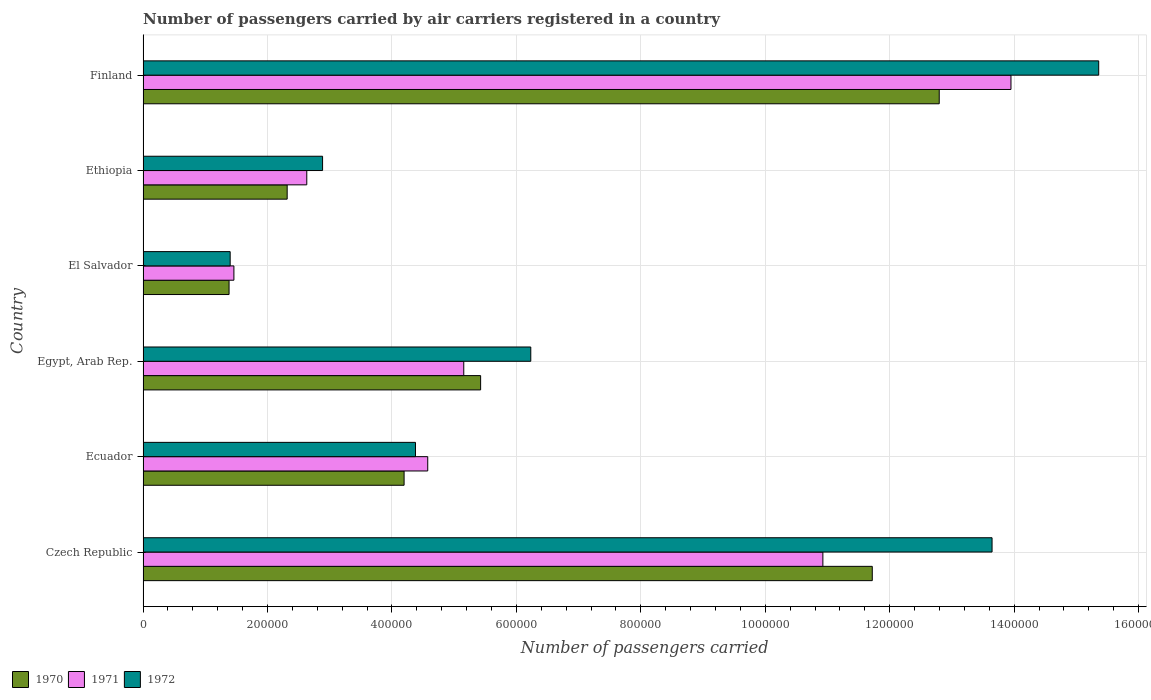How many groups of bars are there?
Give a very brief answer. 6. Are the number of bars per tick equal to the number of legend labels?
Your response must be concise. Yes. Are the number of bars on each tick of the Y-axis equal?
Your answer should be very brief. Yes. How many bars are there on the 5th tick from the bottom?
Your response must be concise. 3. What is the label of the 2nd group of bars from the top?
Offer a terse response. Ethiopia. What is the number of passengers carried by air carriers in 1970 in Ecuador?
Offer a terse response. 4.20e+05. Across all countries, what is the maximum number of passengers carried by air carriers in 1972?
Offer a very short reply. 1.54e+06. In which country was the number of passengers carried by air carriers in 1971 minimum?
Give a very brief answer. El Salvador. What is the total number of passengers carried by air carriers in 1970 in the graph?
Your answer should be compact. 3.78e+06. What is the difference between the number of passengers carried by air carriers in 1972 in El Salvador and that in Ethiopia?
Keep it short and to the point. -1.48e+05. What is the difference between the number of passengers carried by air carriers in 1971 in El Salvador and the number of passengers carried by air carriers in 1972 in Finland?
Offer a very short reply. -1.39e+06. What is the average number of passengers carried by air carriers in 1970 per country?
Make the answer very short. 6.31e+05. What is the difference between the number of passengers carried by air carriers in 1971 and number of passengers carried by air carriers in 1970 in Finland?
Ensure brevity in your answer.  1.15e+05. In how many countries, is the number of passengers carried by air carriers in 1970 greater than 1080000 ?
Provide a short and direct response. 2. What is the ratio of the number of passengers carried by air carriers in 1970 in El Salvador to that in Finland?
Give a very brief answer. 0.11. Is the number of passengers carried by air carriers in 1972 in Egypt, Arab Rep. less than that in Ethiopia?
Make the answer very short. No. What is the difference between the highest and the second highest number of passengers carried by air carriers in 1972?
Give a very brief answer. 1.71e+05. What is the difference between the highest and the lowest number of passengers carried by air carriers in 1970?
Give a very brief answer. 1.14e+06. In how many countries, is the number of passengers carried by air carriers in 1971 greater than the average number of passengers carried by air carriers in 1971 taken over all countries?
Your answer should be very brief. 2. What does the 2nd bar from the top in Czech Republic represents?
Your answer should be very brief. 1971. What does the 1st bar from the bottom in Ecuador represents?
Make the answer very short. 1970. Are all the bars in the graph horizontal?
Offer a terse response. Yes. How many countries are there in the graph?
Provide a succinct answer. 6. Are the values on the major ticks of X-axis written in scientific E-notation?
Provide a succinct answer. No. Does the graph contain grids?
Your answer should be compact. Yes. Where does the legend appear in the graph?
Provide a succinct answer. Bottom left. How many legend labels are there?
Offer a terse response. 3. What is the title of the graph?
Provide a succinct answer. Number of passengers carried by air carriers registered in a country. Does "1988" appear as one of the legend labels in the graph?
Offer a terse response. No. What is the label or title of the X-axis?
Provide a succinct answer. Number of passengers carried. What is the label or title of the Y-axis?
Give a very brief answer. Country. What is the Number of passengers carried in 1970 in Czech Republic?
Ensure brevity in your answer.  1.17e+06. What is the Number of passengers carried of 1971 in Czech Republic?
Your answer should be very brief. 1.09e+06. What is the Number of passengers carried of 1972 in Czech Republic?
Offer a terse response. 1.36e+06. What is the Number of passengers carried in 1970 in Ecuador?
Your answer should be very brief. 4.20e+05. What is the Number of passengers carried in 1971 in Ecuador?
Your response must be concise. 4.58e+05. What is the Number of passengers carried in 1972 in Ecuador?
Your answer should be very brief. 4.38e+05. What is the Number of passengers carried in 1970 in Egypt, Arab Rep.?
Give a very brief answer. 5.42e+05. What is the Number of passengers carried of 1971 in Egypt, Arab Rep.?
Your response must be concise. 5.15e+05. What is the Number of passengers carried in 1972 in Egypt, Arab Rep.?
Ensure brevity in your answer.  6.23e+05. What is the Number of passengers carried in 1970 in El Salvador?
Give a very brief answer. 1.38e+05. What is the Number of passengers carried of 1971 in El Salvador?
Your response must be concise. 1.46e+05. What is the Number of passengers carried of 1972 in El Salvador?
Your answer should be very brief. 1.40e+05. What is the Number of passengers carried in 1970 in Ethiopia?
Your response must be concise. 2.32e+05. What is the Number of passengers carried of 1971 in Ethiopia?
Give a very brief answer. 2.63e+05. What is the Number of passengers carried of 1972 in Ethiopia?
Provide a succinct answer. 2.88e+05. What is the Number of passengers carried in 1970 in Finland?
Offer a terse response. 1.28e+06. What is the Number of passengers carried in 1971 in Finland?
Keep it short and to the point. 1.39e+06. What is the Number of passengers carried in 1972 in Finland?
Offer a very short reply. 1.54e+06. Across all countries, what is the maximum Number of passengers carried of 1970?
Offer a very short reply. 1.28e+06. Across all countries, what is the maximum Number of passengers carried in 1971?
Provide a succinct answer. 1.39e+06. Across all countries, what is the maximum Number of passengers carried in 1972?
Your answer should be compact. 1.54e+06. Across all countries, what is the minimum Number of passengers carried of 1970?
Give a very brief answer. 1.38e+05. Across all countries, what is the minimum Number of passengers carried of 1971?
Provide a short and direct response. 1.46e+05. What is the total Number of passengers carried in 1970 in the graph?
Your answer should be very brief. 3.78e+06. What is the total Number of passengers carried of 1971 in the graph?
Your response must be concise. 3.87e+06. What is the total Number of passengers carried in 1972 in the graph?
Give a very brief answer. 4.39e+06. What is the difference between the Number of passengers carried of 1970 in Czech Republic and that in Ecuador?
Your answer should be compact. 7.52e+05. What is the difference between the Number of passengers carried in 1971 in Czech Republic and that in Ecuador?
Make the answer very short. 6.35e+05. What is the difference between the Number of passengers carried in 1972 in Czech Republic and that in Ecuador?
Provide a short and direct response. 9.27e+05. What is the difference between the Number of passengers carried in 1970 in Czech Republic and that in Egypt, Arab Rep.?
Give a very brief answer. 6.29e+05. What is the difference between the Number of passengers carried in 1971 in Czech Republic and that in Egypt, Arab Rep.?
Your response must be concise. 5.77e+05. What is the difference between the Number of passengers carried of 1972 in Czech Republic and that in Egypt, Arab Rep.?
Make the answer very short. 7.41e+05. What is the difference between the Number of passengers carried in 1970 in Czech Republic and that in El Salvador?
Offer a terse response. 1.03e+06. What is the difference between the Number of passengers carried of 1971 in Czech Republic and that in El Salvador?
Keep it short and to the point. 9.46e+05. What is the difference between the Number of passengers carried in 1972 in Czech Republic and that in El Salvador?
Offer a terse response. 1.22e+06. What is the difference between the Number of passengers carried of 1970 in Czech Republic and that in Ethiopia?
Keep it short and to the point. 9.40e+05. What is the difference between the Number of passengers carried of 1971 in Czech Republic and that in Ethiopia?
Make the answer very short. 8.29e+05. What is the difference between the Number of passengers carried in 1972 in Czech Republic and that in Ethiopia?
Keep it short and to the point. 1.08e+06. What is the difference between the Number of passengers carried of 1970 in Czech Republic and that in Finland?
Your response must be concise. -1.08e+05. What is the difference between the Number of passengers carried in 1971 in Czech Republic and that in Finland?
Give a very brief answer. -3.02e+05. What is the difference between the Number of passengers carried in 1972 in Czech Republic and that in Finland?
Provide a short and direct response. -1.71e+05. What is the difference between the Number of passengers carried of 1970 in Ecuador and that in Egypt, Arab Rep.?
Provide a short and direct response. -1.23e+05. What is the difference between the Number of passengers carried of 1971 in Ecuador and that in Egypt, Arab Rep.?
Ensure brevity in your answer.  -5.79e+04. What is the difference between the Number of passengers carried in 1972 in Ecuador and that in Egypt, Arab Rep.?
Provide a succinct answer. -1.85e+05. What is the difference between the Number of passengers carried in 1970 in Ecuador and that in El Salvador?
Give a very brief answer. 2.81e+05. What is the difference between the Number of passengers carried of 1971 in Ecuador and that in El Salvador?
Offer a terse response. 3.12e+05. What is the difference between the Number of passengers carried of 1972 in Ecuador and that in El Salvador?
Make the answer very short. 2.98e+05. What is the difference between the Number of passengers carried of 1970 in Ecuador and that in Ethiopia?
Give a very brief answer. 1.88e+05. What is the difference between the Number of passengers carried in 1971 in Ecuador and that in Ethiopia?
Offer a terse response. 1.94e+05. What is the difference between the Number of passengers carried in 1972 in Ecuador and that in Ethiopia?
Keep it short and to the point. 1.49e+05. What is the difference between the Number of passengers carried in 1970 in Ecuador and that in Finland?
Make the answer very short. -8.60e+05. What is the difference between the Number of passengers carried in 1971 in Ecuador and that in Finland?
Ensure brevity in your answer.  -9.37e+05. What is the difference between the Number of passengers carried of 1972 in Ecuador and that in Finland?
Your answer should be very brief. -1.10e+06. What is the difference between the Number of passengers carried in 1970 in Egypt, Arab Rep. and that in El Salvador?
Your response must be concise. 4.04e+05. What is the difference between the Number of passengers carried of 1971 in Egypt, Arab Rep. and that in El Salvador?
Ensure brevity in your answer.  3.69e+05. What is the difference between the Number of passengers carried in 1972 in Egypt, Arab Rep. and that in El Salvador?
Keep it short and to the point. 4.83e+05. What is the difference between the Number of passengers carried of 1970 in Egypt, Arab Rep. and that in Ethiopia?
Offer a terse response. 3.11e+05. What is the difference between the Number of passengers carried of 1971 in Egypt, Arab Rep. and that in Ethiopia?
Provide a short and direct response. 2.52e+05. What is the difference between the Number of passengers carried in 1972 in Egypt, Arab Rep. and that in Ethiopia?
Ensure brevity in your answer.  3.35e+05. What is the difference between the Number of passengers carried in 1970 in Egypt, Arab Rep. and that in Finland?
Ensure brevity in your answer.  -7.37e+05. What is the difference between the Number of passengers carried in 1971 in Egypt, Arab Rep. and that in Finland?
Keep it short and to the point. -8.79e+05. What is the difference between the Number of passengers carried in 1972 in Egypt, Arab Rep. and that in Finland?
Offer a terse response. -9.13e+05. What is the difference between the Number of passengers carried in 1970 in El Salvador and that in Ethiopia?
Give a very brief answer. -9.34e+04. What is the difference between the Number of passengers carried in 1971 in El Salvador and that in Ethiopia?
Your answer should be compact. -1.17e+05. What is the difference between the Number of passengers carried in 1972 in El Salvador and that in Ethiopia?
Give a very brief answer. -1.48e+05. What is the difference between the Number of passengers carried in 1970 in El Salvador and that in Finland?
Your response must be concise. -1.14e+06. What is the difference between the Number of passengers carried of 1971 in El Salvador and that in Finland?
Offer a terse response. -1.25e+06. What is the difference between the Number of passengers carried of 1972 in El Salvador and that in Finland?
Your response must be concise. -1.40e+06. What is the difference between the Number of passengers carried in 1970 in Ethiopia and that in Finland?
Offer a very short reply. -1.05e+06. What is the difference between the Number of passengers carried in 1971 in Ethiopia and that in Finland?
Make the answer very short. -1.13e+06. What is the difference between the Number of passengers carried of 1972 in Ethiopia and that in Finland?
Your answer should be very brief. -1.25e+06. What is the difference between the Number of passengers carried in 1970 in Czech Republic and the Number of passengers carried in 1971 in Ecuador?
Provide a succinct answer. 7.14e+05. What is the difference between the Number of passengers carried in 1970 in Czech Republic and the Number of passengers carried in 1972 in Ecuador?
Offer a terse response. 7.34e+05. What is the difference between the Number of passengers carried in 1971 in Czech Republic and the Number of passengers carried in 1972 in Ecuador?
Keep it short and to the point. 6.55e+05. What is the difference between the Number of passengers carried in 1970 in Czech Republic and the Number of passengers carried in 1971 in Egypt, Arab Rep.?
Make the answer very short. 6.56e+05. What is the difference between the Number of passengers carried of 1970 in Czech Republic and the Number of passengers carried of 1972 in Egypt, Arab Rep.?
Provide a succinct answer. 5.49e+05. What is the difference between the Number of passengers carried of 1971 in Czech Republic and the Number of passengers carried of 1972 in Egypt, Arab Rep.?
Provide a succinct answer. 4.69e+05. What is the difference between the Number of passengers carried in 1970 in Czech Republic and the Number of passengers carried in 1971 in El Salvador?
Give a very brief answer. 1.03e+06. What is the difference between the Number of passengers carried in 1970 in Czech Republic and the Number of passengers carried in 1972 in El Salvador?
Make the answer very short. 1.03e+06. What is the difference between the Number of passengers carried in 1971 in Czech Republic and the Number of passengers carried in 1972 in El Salvador?
Ensure brevity in your answer.  9.52e+05. What is the difference between the Number of passengers carried in 1970 in Czech Republic and the Number of passengers carried in 1971 in Ethiopia?
Offer a terse response. 9.09e+05. What is the difference between the Number of passengers carried of 1970 in Czech Republic and the Number of passengers carried of 1972 in Ethiopia?
Your response must be concise. 8.83e+05. What is the difference between the Number of passengers carried of 1971 in Czech Republic and the Number of passengers carried of 1972 in Ethiopia?
Offer a terse response. 8.04e+05. What is the difference between the Number of passengers carried of 1970 in Czech Republic and the Number of passengers carried of 1971 in Finland?
Provide a short and direct response. -2.23e+05. What is the difference between the Number of passengers carried of 1970 in Czech Republic and the Number of passengers carried of 1972 in Finland?
Provide a succinct answer. -3.64e+05. What is the difference between the Number of passengers carried of 1971 in Czech Republic and the Number of passengers carried of 1972 in Finland?
Your answer should be compact. -4.43e+05. What is the difference between the Number of passengers carried of 1970 in Ecuador and the Number of passengers carried of 1971 in Egypt, Arab Rep.?
Ensure brevity in your answer.  -9.59e+04. What is the difference between the Number of passengers carried of 1970 in Ecuador and the Number of passengers carried of 1972 in Egypt, Arab Rep.?
Offer a terse response. -2.04e+05. What is the difference between the Number of passengers carried in 1971 in Ecuador and the Number of passengers carried in 1972 in Egypt, Arab Rep.?
Your response must be concise. -1.66e+05. What is the difference between the Number of passengers carried in 1970 in Ecuador and the Number of passengers carried in 1971 in El Salvador?
Make the answer very short. 2.74e+05. What is the difference between the Number of passengers carried in 1970 in Ecuador and the Number of passengers carried in 1972 in El Salvador?
Provide a succinct answer. 2.80e+05. What is the difference between the Number of passengers carried of 1971 in Ecuador and the Number of passengers carried of 1972 in El Salvador?
Provide a succinct answer. 3.18e+05. What is the difference between the Number of passengers carried in 1970 in Ecuador and the Number of passengers carried in 1971 in Ethiopia?
Ensure brevity in your answer.  1.56e+05. What is the difference between the Number of passengers carried in 1970 in Ecuador and the Number of passengers carried in 1972 in Ethiopia?
Your answer should be compact. 1.31e+05. What is the difference between the Number of passengers carried in 1971 in Ecuador and the Number of passengers carried in 1972 in Ethiopia?
Your answer should be compact. 1.69e+05. What is the difference between the Number of passengers carried in 1970 in Ecuador and the Number of passengers carried in 1971 in Finland?
Your answer should be compact. -9.75e+05. What is the difference between the Number of passengers carried in 1970 in Ecuador and the Number of passengers carried in 1972 in Finland?
Your answer should be very brief. -1.12e+06. What is the difference between the Number of passengers carried in 1971 in Ecuador and the Number of passengers carried in 1972 in Finland?
Provide a short and direct response. -1.08e+06. What is the difference between the Number of passengers carried in 1970 in Egypt, Arab Rep. and the Number of passengers carried in 1971 in El Salvador?
Offer a very short reply. 3.96e+05. What is the difference between the Number of passengers carried of 1970 in Egypt, Arab Rep. and the Number of passengers carried of 1972 in El Salvador?
Ensure brevity in your answer.  4.02e+05. What is the difference between the Number of passengers carried of 1971 in Egypt, Arab Rep. and the Number of passengers carried of 1972 in El Salvador?
Provide a succinct answer. 3.75e+05. What is the difference between the Number of passengers carried in 1970 in Egypt, Arab Rep. and the Number of passengers carried in 1971 in Ethiopia?
Make the answer very short. 2.79e+05. What is the difference between the Number of passengers carried in 1970 in Egypt, Arab Rep. and the Number of passengers carried in 1972 in Ethiopia?
Your answer should be compact. 2.54e+05. What is the difference between the Number of passengers carried of 1971 in Egypt, Arab Rep. and the Number of passengers carried of 1972 in Ethiopia?
Your answer should be compact. 2.27e+05. What is the difference between the Number of passengers carried of 1970 in Egypt, Arab Rep. and the Number of passengers carried of 1971 in Finland?
Your answer should be very brief. -8.52e+05. What is the difference between the Number of passengers carried of 1970 in Egypt, Arab Rep. and the Number of passengers carried of 1972 in Finland?
Your answer should be very brief. -9.93e+05. What is the difference between the Number of passengers carried in 1971 in Egypt, Arab Rep. and the Number of passengers carried in 1972 in Finland?
Ensure brevity in your answer.  -1.02e+06. What is the difference between the Number of passengers carried of 1970 in El Salvador and the Number of passengers carried of 1971 in Ethiopia?
Your answer should be compact. -1.25e+05. What is the difference between the Number of passengers carried in 1970 in El Salvador and the Number of passengers carried in 1972 in Ethiopia?
Your response must be concise. -1.50e+05. What is the difference between the Number of passengers carried of 1971 in El Salvador and the Number of passengers carried of 1972 in Ethiopia?
Provide a short and direct response. -1.42e+05. What is the difference between the Number of passengers carried in 1970 in El Salvador and the Number of passengers carried in 1971 in Finland?
Offer a very short reply. -1.26e+06. What is the difference between the Number of passengers carried in 1970 in El Salvador and the Number of passengers carried in 1972 in Finland?
Give a very brief answer. -1.40e+06. What is the difference between the Number of passengers carried of 1971 in El Salvador and the Number of passengers carried of 1972 in Finland?
Offer a very short reply. -1.39e+06. What is the difference between the Number of passengers carried in 1970 in Ethiopia and the Number of passengers carried in 1971 in Finland?
Offer a very short reply. -1.16e+06. What is the difference between the Number of passengers carried in 1970 in Ethiopia and the Number of passengers carried in 1972 in Finland?
Offer a very short reply. -1.30e+06. What is the difference between the Number of passengers carried in 1971 in Ethiopia and the Number of passengers carried in 1972 in Finland?
Keep it short and to the point. -1.27e+06. What is the average Number of passengers carried of 1970 per country?
Offer a very short reply. 6.31e+05. What is the average Number of passengers carried of 1971 per country?
Provide a succinct answer. 6.45e+05. What is the average Number of passengers carried of 1972 per country?
Give a very brief answer. 7.32e+05. What is the difference between the Number of passengers carried of 1970 and Number of passengers carried of 1971 in Czech Republic?
Offer a terse response. 7.94e+04. What is the difference between the Number of passengers carried of 1970 and Number of passengers carried of 1972 in Czech Republic?
Make the answer very short. -1.92e+05. What is the difference between the Number of passengers carried of 1971 and Number of passengers carried of 1972 in Czech Republic?
Your answer should be compact. -2.72e+05. What is the difference between the Number of passengers carried in 1970 and Number of passengers carried in 1971 in Ecuador?
Your response must be concise. -3.80e+04. What is the difference between the Number of passengers carried of 1970 and Number of passengers carried of 1972 in Ecuador?
Offer a very short reply. -1.83e+04. What is the difference between the Number of passengers carried of 1971 and Number of passengers carried of 1972 in Ecuador?
Make the answer very short. 1.97e+04. What is the difference between the Number of passengers carried of 1970 and Number of passengers carried of 1971 in Egypt, Arab Rep.?
Offer a terse response. 2.71e+04. What is the difference between the Number of passengers carried in 1970 and Number of passengers carried in 1972 in Egypt, Arab Rep.?
Keep it short and to the point. -8.06e+04. What is the difference between the Number of passengers carried of 1971 and Number of passengers carried of 1972 in Egypt, Arab Rep.?
Provide a succinct answer. -1.08e+05. What is the difference between the Number of passengers carried of 1970 and Number of passengers carried of 1971 in El Salvador?
Ensure brevity in your answer.  -7800. What is the difference between the Number of passengers carried in 1970 and Number of passengers carried in 1972 in El Salvador?
Your response must be concise. -1800. What is the difference between the Number of passengers carried of 1971 and Number of passengers carried of 1972 in El Salvador?
Offer a very short reply. 6000. What is the difference between the Number of passengers carried in 1970 and Number of passengers carried in 1971 in Ethiopia?
Offer a terse response. -3.15e+04. What is the difference between the Number of passengers carried of 1970 and Number of passengers carried of 1972 in Ethiopia?
Provide a succinct answer. -5.69e+04. What is the difference between the Number of passengers carried in 1971 and Number of passengers carried in 1972 in Ethiopia?
Make the answer very short. -2.54e+04. What is the difference between the Number of passengers carried of 1970 and Number of passengers carried of 1971 in Finland?
Your response must be concise. -1.15e+05. What is the difference between the Number of passengers carried of 1970 and Number of passengers carried of 1972 in Finland?
Your answer should be compact. -2.56e+05. What is the difference between the Number of passengers carried of 1971 and Number of passengers carried of 1972 in Finland?
Your answer should be very brief. -1.41e+05. What is the ratio of the Number of passengers carried in 1970 in Czech Republic to that in Ecuador?
Provide a succinct answer. 2.79. What is the ratio of the Number of passengers carried in 1971 in Czech Republic to that in Ecuador?
Ensure brevity in your answer.  2.39. What is the ratio of the Number of passengers carried of 1972 in Czech Republic to that in Ecuador?
Your answer should be very brief. 3.12. What is the ratio of the Number of passengers carried in 1970 in Czech Republic to that in Egypt, Arab Rep.?
Offer a terse response. 2.16. What is the ratio of the Number of passengers carried of 1971 in Czech Republic to that in Egypt, Arab Rep.?
Keep it short and to the point. 2.12. What is the ratio of the Number of passengers carried of 1972 in Czech Republic to that in Egypt, Arab Rep.?
Your answer should be very brief. 2.19. What is the ratio of the Number of passengers carried in 1970 in Czech Republic to that in El Salvador?
Keep it short and to the point. 8.48. What is the ratio of the Number of passengers carried of 1971 in Czech Republic to that in El Salvador?
Your answer should be very brief. 7.48. What is the ratio of the Number of passengers carried in 1972 in Czech Republic to that in El Salvador?
Ensure brevity in your answer.  9.75. What is the ratio of the Number of passengers carried in 1970 in Czech Republic to that in Ethiopia?
Your response must be concise. 5.06. What is the ratio of the Number of passengers carried in 1971 in Czech Republic to that in Ethiopia?
Offer a terse response. 4.15. What is the ratio of the Number of passengers carried in 1972 in Czech Republic to that in Ethiopia?
Your response must be concise. 4.73. What is the ratio of the Number of passengers carried in 1970 in Czech Republic to that in Finland?
Give a very brief answer. 0.92. What is the ratio of the Number of passengers carried of 1971 in Czech Republic to that in Finland?
Provide a short and direct response. 0.78. What is the ratio of the Number of passengers carried of 1972 in Czech Republic to that in Finland?
Provide a short and direct response. 0.89. What is the ratio of the Number of passengers carried of 1970 in Ecuador to that in Egypt, Arab Rep.?
Your response must be concise. 0.77. What is the ratio of the Number of passengers carried of 1971 in Ecuador to that in Egypt, Arab Rep.?
Your answer should be compact. 0.89. What is the ratio of the Number of passengers carried in 1972 in Ecuador to that in Egypt, Arab Rep.?
Offer a very short reply. 0.7. What is the ratio of the Number of passengers carried in 1970 in Ecuador to that in El Salvador?
Make the answer very short. 3.04. What is the ratio of the Number of passengers carried in 1971 in Ecuador to that in El Salvador?
Provide a succinct answer. 3.13. What is the ratio of the Number of passengers carried of 1972 in Ecuador to that in El Salvador?
Offer a terse response. 3.13. What is the ratio of the Number of passengers carried of 1970 in Ecuador to that in Ethiopia?
Provide a succinct answer. 1.81. What is the ratio of the Number of passengers carried in 1971 in Ecuador to that in Ethiopia?
Provide a succinct answer. 1.74. What is the ratio of the Number of passengers carried of 1972 in Ecuador to that in Ethiopia?
Ensure brevity in your answer.  1.52. What is the ratio of the Number of passengers carried of 1970 in Ecuador to that in Finland?
Your answer should be compact. 0.33. What is the ratio of the Number of passengers carried in 1971 in Ecuador to that in Finland?
Provide a short and direct response. 0.33. What is the ratio of the Number of passengers carried of 1972 in Ecuador to that in Finland?
Offer a terse response. 0.29. What is the ratio of the Number of passengers carried in 1970 in Egypt, Arab Rep. to that in El Salvador?
Provide a short and direct response. 3.93. What is the ratio of the Number of passengers carried of 1971 in Egypt, Arab Rep. to that in El Salvador?
Keep it short and to the point. 3.53. What is the ratio of the Number of passengers carried in 1972 in Egypt, Arab Rep. to that in El Salvador?
Provide a succinct answer. 4.45. What is the ratio of the Number of passengers carried of 1970 in Egypt, Arab Rep. to that in Ethiopia?
Your response must be concise. 2.34. What is the ratio of the Number of passengers carried of 1971 in Egypt, Arab Rep. to that in Ethiopia?
Ensure brevity in your answer.  1.96. What is the ratio of the Number of passengers carried in 1972 in Egypt, Arab Rep. to that in Ethiopia?
Your response must be concise. 2.16. What is the ratio of the Number of passengers carried of 1970 in Egypt, Arab Rep. to that in Finland?
Make the answer very short. 0.42. What is the ratio of the Number of passengers carried of 1971 in Egypt, Arab Rep. to that in Finland?
Keep it short and to the point. 0.37. What is the ratio of the Number of passengers carried in 1972 in Egypt, Arab Rep. to that in Finland?
Your response must be concise. 0.41. What is the ratio of the Number of passengers carried in 1970 in El Salvador to that in Ethiopia?
Offer a terse response. 0.6. What is the ratio of the Number of passengers carried of 1971 in El Salvador to that in Ethiopia?
Keep it short and to the point. 0.55. What is the ratio of the Number of passengers carried of 1972 in El Salvador to that in Ethiopia?
Offer a very short reply. 0.49. What is the ratio of the Number of passengers carried of 1970 in El Salvador to that in Finland?
Provide a succinct answer. 0.11. What is the ratio of the Number of passengers carried of 1971 in El Salvador to that in Finland?
Your answer should be compact. 0.1. What is the ratio of the Number of passengers carried of 1972 in El Salvador to that in Finland?
Offer a very short reply. 0.09. What is the ratio of the Number of passengers carried of 1970 in Ethiopia to that in Finland?
Provide a short and direct response. 0.18. What is the ratio of the Number of passengers carried of 1971 in Ethiopia to that in Finland?
Provide a short and direct response. 0.19. What is the ratio of the Number of passengers carried in 1972 in Ethiopia to that in Finland?
Keep it short and to the point. 0.19. What is the difference between the highest and the second highest Number of passengers carried of 1970?
Your answer should be very brief. 1.08e+05. What is the difference between the highest and the second highest Number of passengers carried in 1971?
Provide a succinct answer. 3.02e+05. What is the difference between the highest and the second highest Number of passengers carried in 1972?
Your answer should be very brief. 1.71e+05. What is the difference between the highest and the lowest Number of passengers carried of 1970?
Make the answer very short. 1.14e+06. What is the difference between the highest and the lowest Number of passengers carried in 1971?
Provide a succinct answer. 1.25e+06. What is the difference between the highest and the lowest Number of passengers carried in 1972?
Make the answer very short. 1.40e+06. 